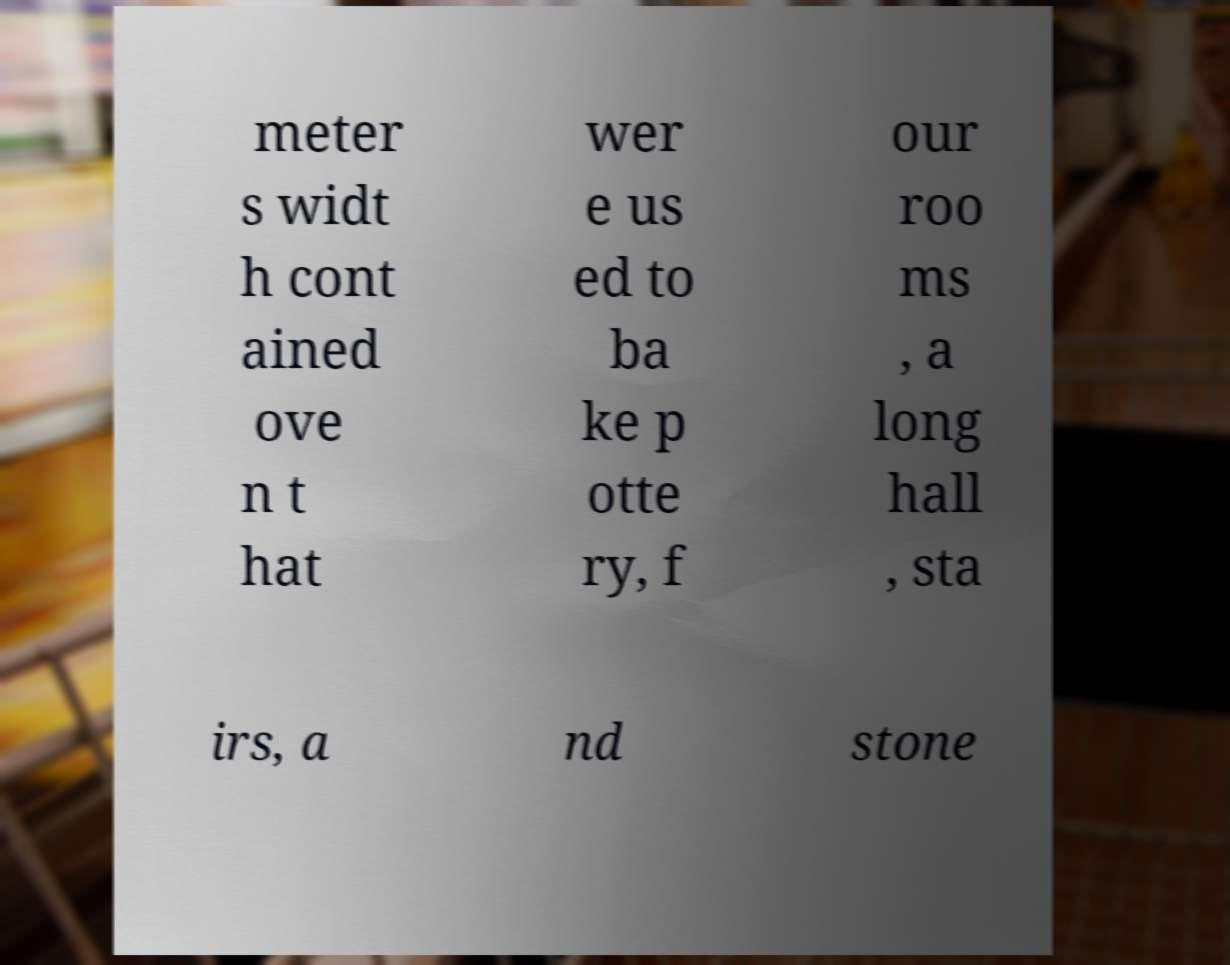Please identify and transcribe the text found in this image. meter s widt h cont ained ove n t hat wer e us ed to ba ke p otte ry, f our roo ms , a long hall , sta irs, a nd stone 